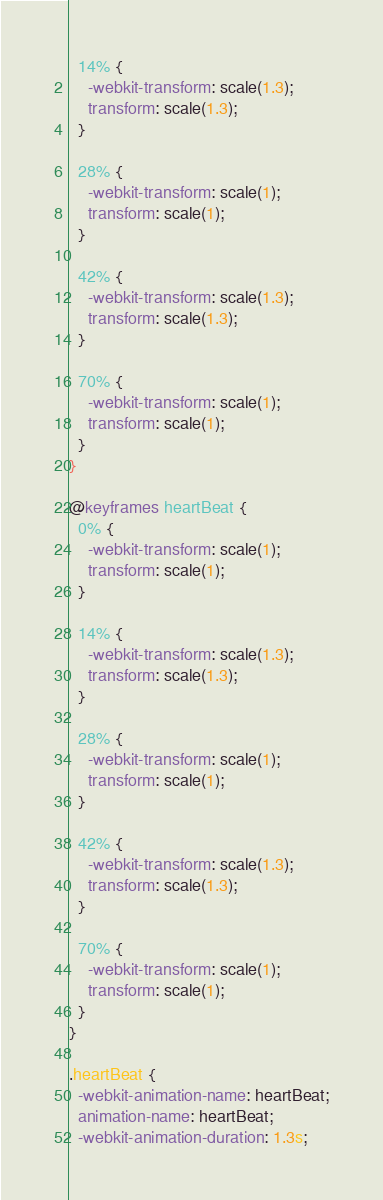<code> <loc_0><loc_0><loc_500><loc_500><_CSS_>  14% {
    -webkit-transform: scale(1.3);
    transform: scale(1.3);
  }

  28% {
    -webkit-transform: scale(1);
    transform: scale(1);
  }

  42% {
    -webkit-transform: scale(1.3);
    transform: scale(1.3);
  }

  70% {
    -webkit-transform: scale(1);
    transform: scale(1);
  }
}

@keyframes heartBeat {
  0% {
    -webkit-transform: scale(1);
    transform: scale(1);
  }

  14% {
    -webkit-transform: scale(1.3);
    transform: scale(1.3);
  }

  28% {
    -webkit-transform: scale(1);
    transform: scale(1);
  }

  42% {
    -webkit-transform: scale(1.3);
    transform: scale(1.3);
  }

  70% {
    -webkit-transform: scale(1);
    transform: scale(1);
  }
}

.heartBeat {
  -webkit-animation-name: heartBeat;
  animation-name: heartBeat;
  -webkit-animation-duration: 1.3s;</code> 